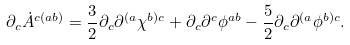<formula> <loc_0><loc_0><loc_500><loc_500>\partial _ { c } { \dot { A } } ^ { c ( a b ) } = \frac { 3 } { 2 } \partial _ { c } \partial ^ { ( a } \chi ^ { b ) c } + \partial _ { c } \partial ^ { c } \phi ^ { a b } - \frac { 5 } { 2 } \partial _ { c } \partial ^ { ( a } \phi ^ { b ) c } .</formula> 